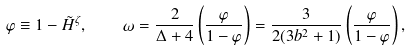<formula> <loc_0><loc_0><loc_500><loc_500>\varphi \equiv 1 - \tilde { H } ^ { \zeta } , \quad \omega = \frac { 2 } { \Delta + 4 } \left ( \frac { \varphi } { 1 - \varphi } \right ) = \frac { 3 } { 2 ( 3 b ^ { 2 } + 1 ) } \left ( \frac { \varphi } { 1 - \varphi } \right ) ,</formula> 